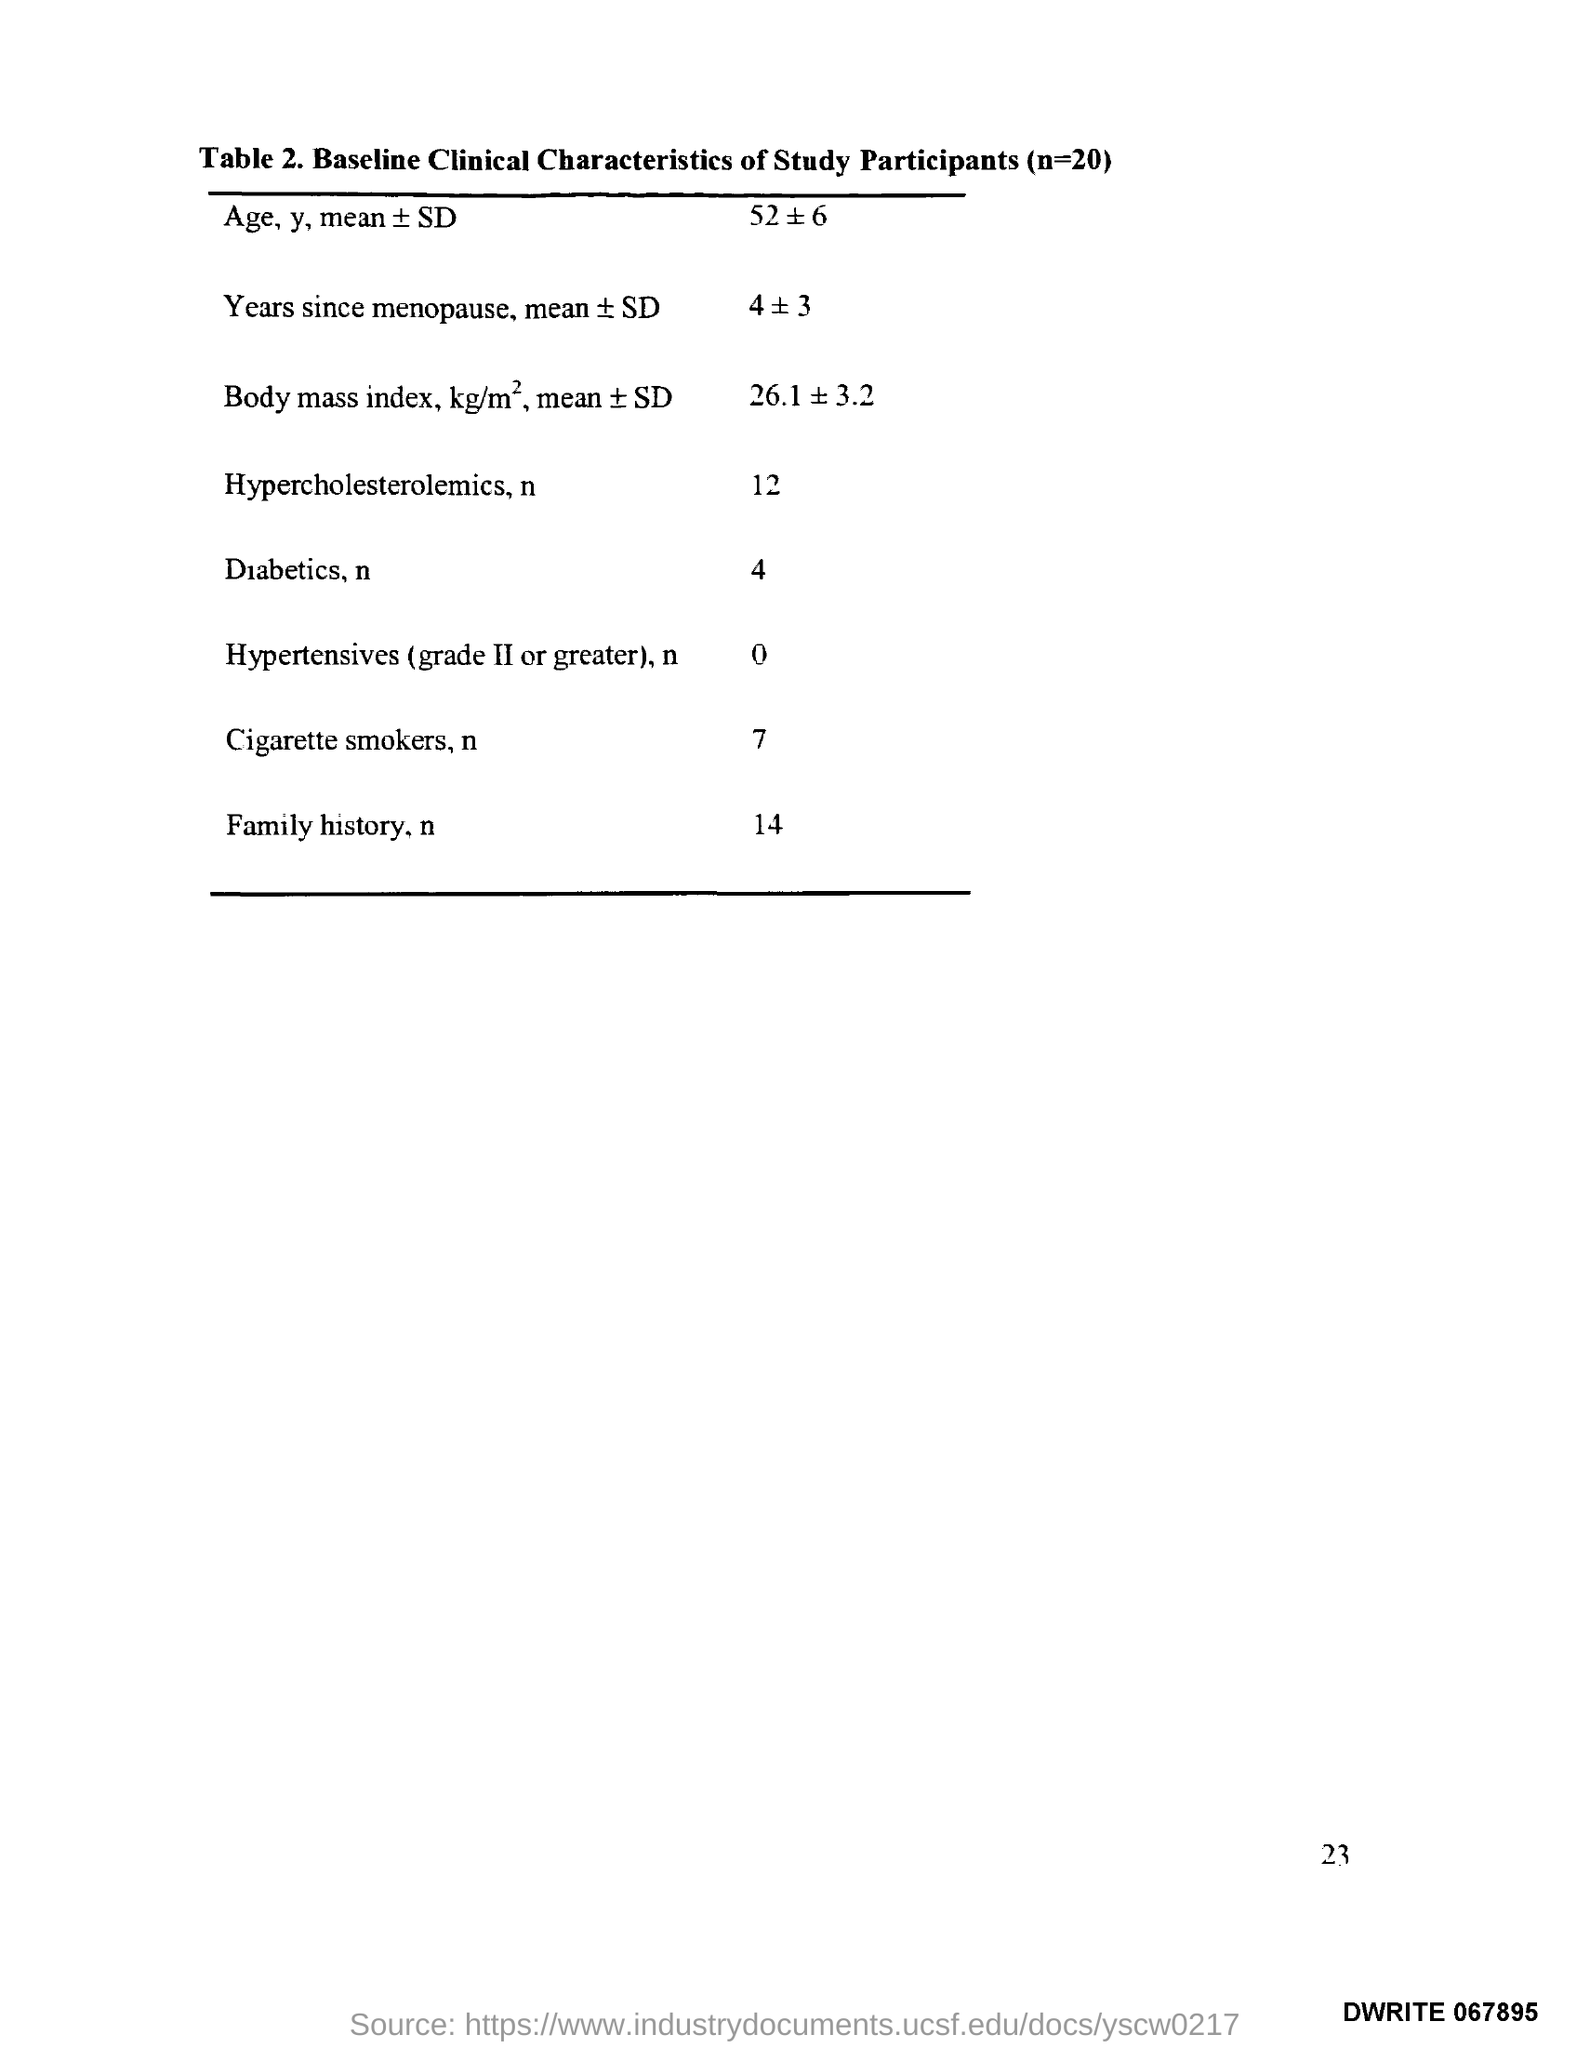Point out several critical features in this image. The page number is 23. 